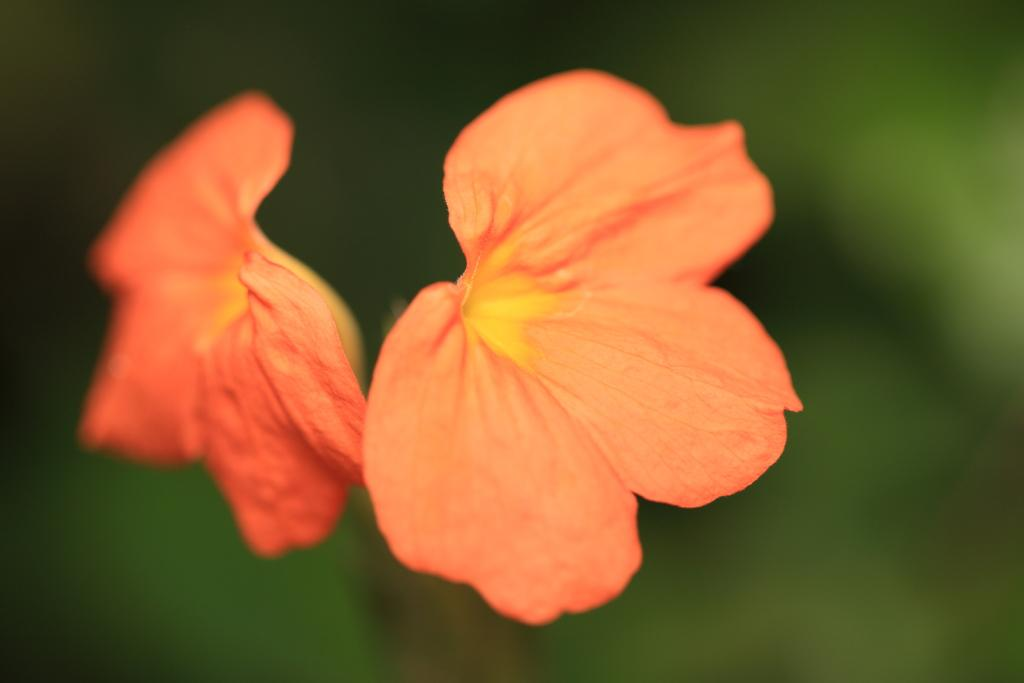What type of flowers are in the foreground of the image? There are two light orange colored flowers in the foreground of the image. What else can be seen around the flowers? There are leaves around the flowers. What type of star can be seen in the image? There is no star present in the image; it features two light orange colored flowers and leaves. Is there a hole in the center of the flowers? There is no hole mentioned in the image; it only describes the presence of two light orange colored flowers and leaves. 